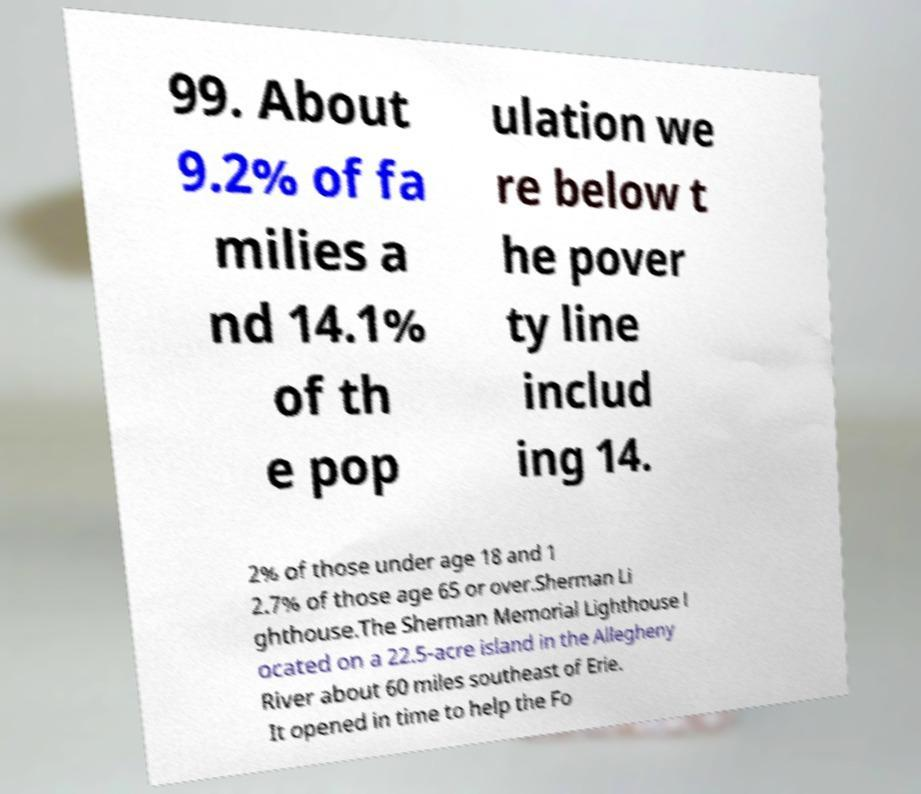Please identify and transcribe the text found in this image. 99. About 9.2% of fa milies a nd 14.1% of th e pop ulation we re below t he pover ty line includ ing 14. 2% of those under age 18 and 1 2.7% of those age 65 or over.Sherman Li ghthouse.The Sherman Memorial Lighthouse l ocated on a 22.5-acre island in the Allegheny River about 60 miles southeast of Erie. It opened in time to help the Fo 